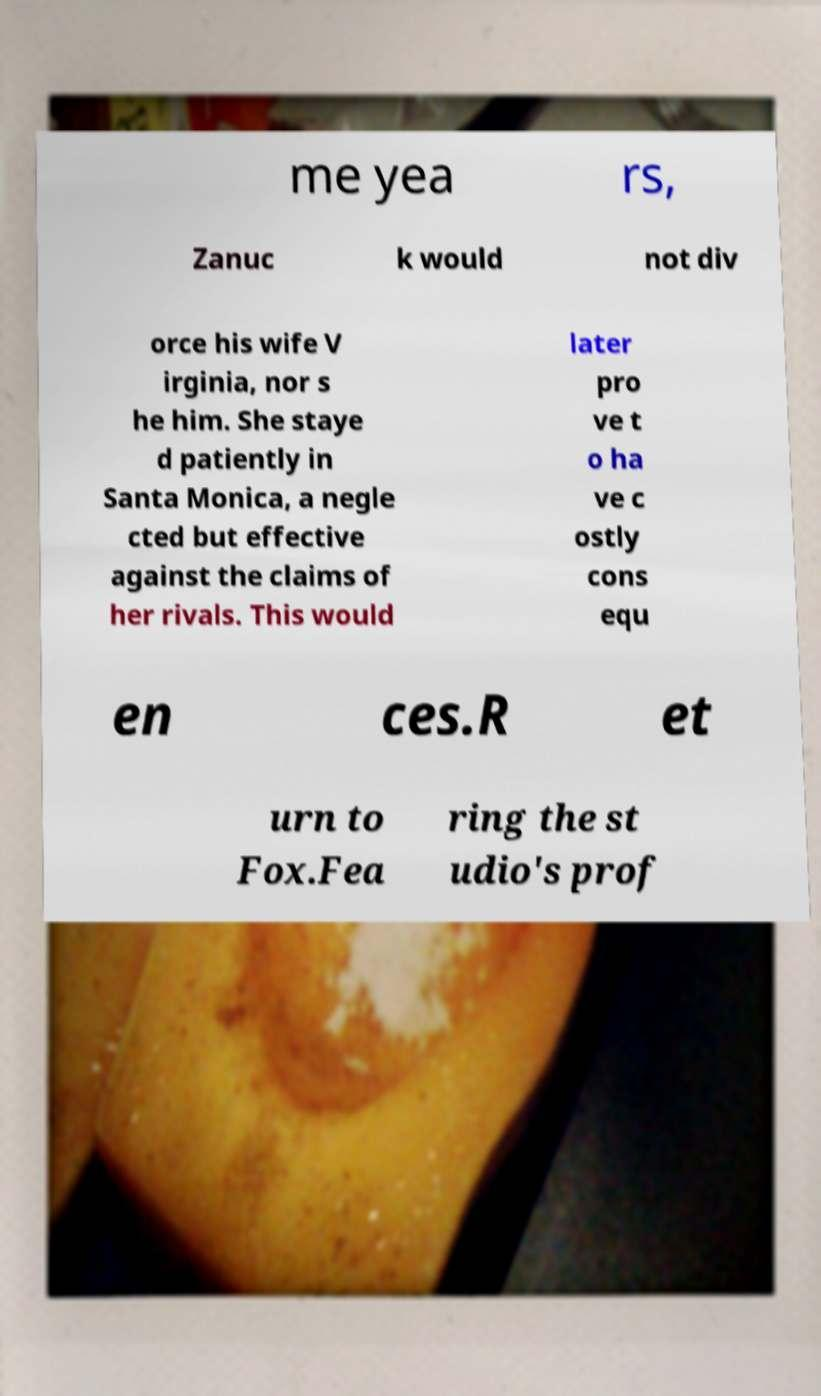Can you accurately transcribe the text from the provided image for me? me yea rs, Zanuc k would not div orce his wife V irginia, nor s he him. She staye d patiently in Santa Monica, a negle cted but effective against the claims of her rivals. This would later pro ve t o ha ve c ostly cons equ en ces.R et urn to Fox.Fea ring the st udio's prof 